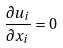<formula> <loc_0><loc_0><loc_500><loc_500>\frac { \partial u _ { i } } { \partial x _ { i } } = 0</formula> 